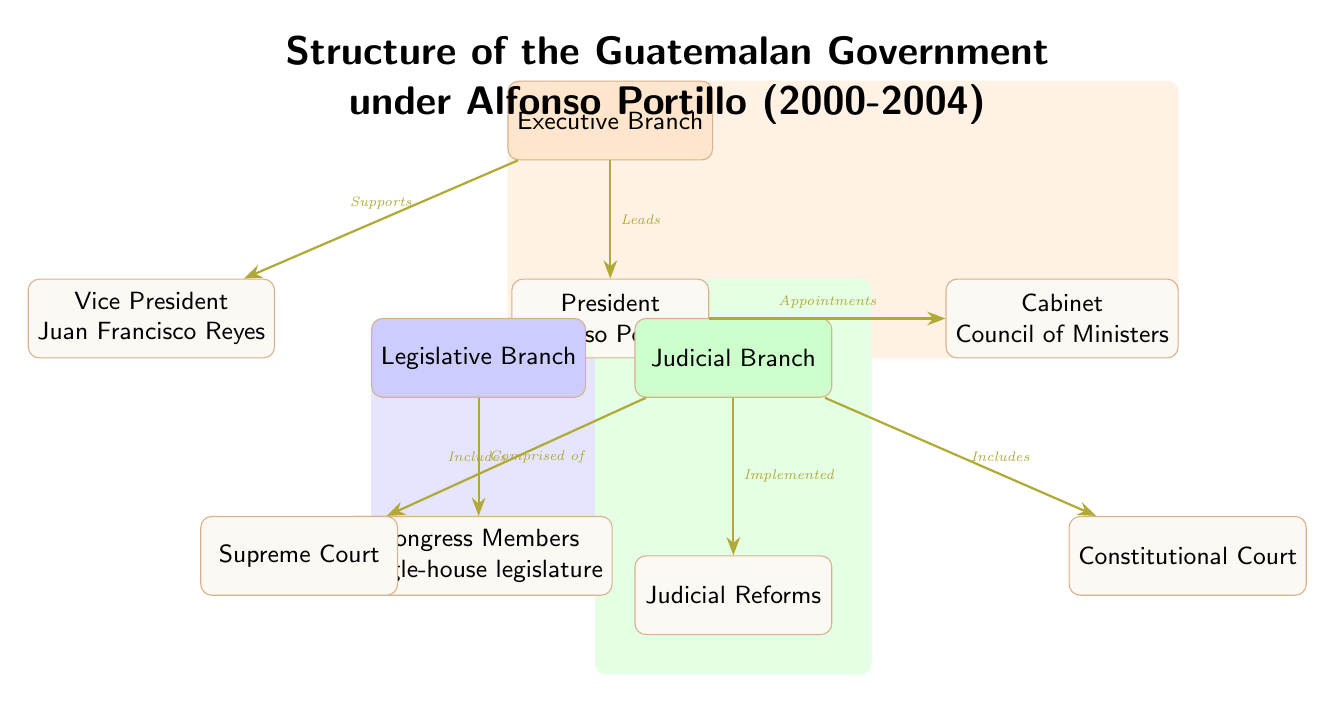What is the title of the diagram? The title is presented at the top of the diagram and explicitly states "Structure of the Guatemalan Government under Alfonso Portillo (2000-2004)," indicating the time period and political figure being depicted.
Answer: Structure of the Guatemalan Government under Alfonso Portillo (2000-2004) Who is the President in the diagram? The diagram identifies the President within the executive branch node, specifically naming Alfonso Portillo as the leader.
Answer: Alfonso Portillo What role does Juan Francisco Reyes hold? Juan Francisco Reyes is positioned directly under the President in the diagram, signifying that he is the Vice President of Guatemala during this tenure.
Answer: Vice President How many branches of government are depicted? The diagram illustrates three branches: Executive, Legislative, and Judicial, which can be counted visually from the layout of the nodes.
Answer: Three Which court is included in the Judicial Branch? The Judicial Branch node includes two specific courts labeled in the diagram: the Supreme Court and the Constitutional Court, of which the Supreme Court is the first mentioned node under Judicial.
Answer: Supreme Court What reform is indicated in the Judicial Branch? The diagram notes "Judicial Reforms" as a component of the Judicial Branch, suggesting efforts towards changes in the judicial system during Portillo's presidency.
Answer: Judicial Reforms What is the relationship between the President and the Cabinet? The diagram shows an arrow from the President to the Cabinet, labeled "Appointments," indicating the President's authority to select members of the Cabinet as part of his role.
Answer: Appointments Which branch includes Congress Members? The Legislative Branch is depicted in the diagram that comprises Congress Members, clearly stating its role in the government’s structure.
Answer: Legislative Branch What is the color indicating the Executive Branch in the diagram? The Executive Branch is represented in orange within the diagram, helping distinguish it from the other branches through color coding.
Answer: Orange 